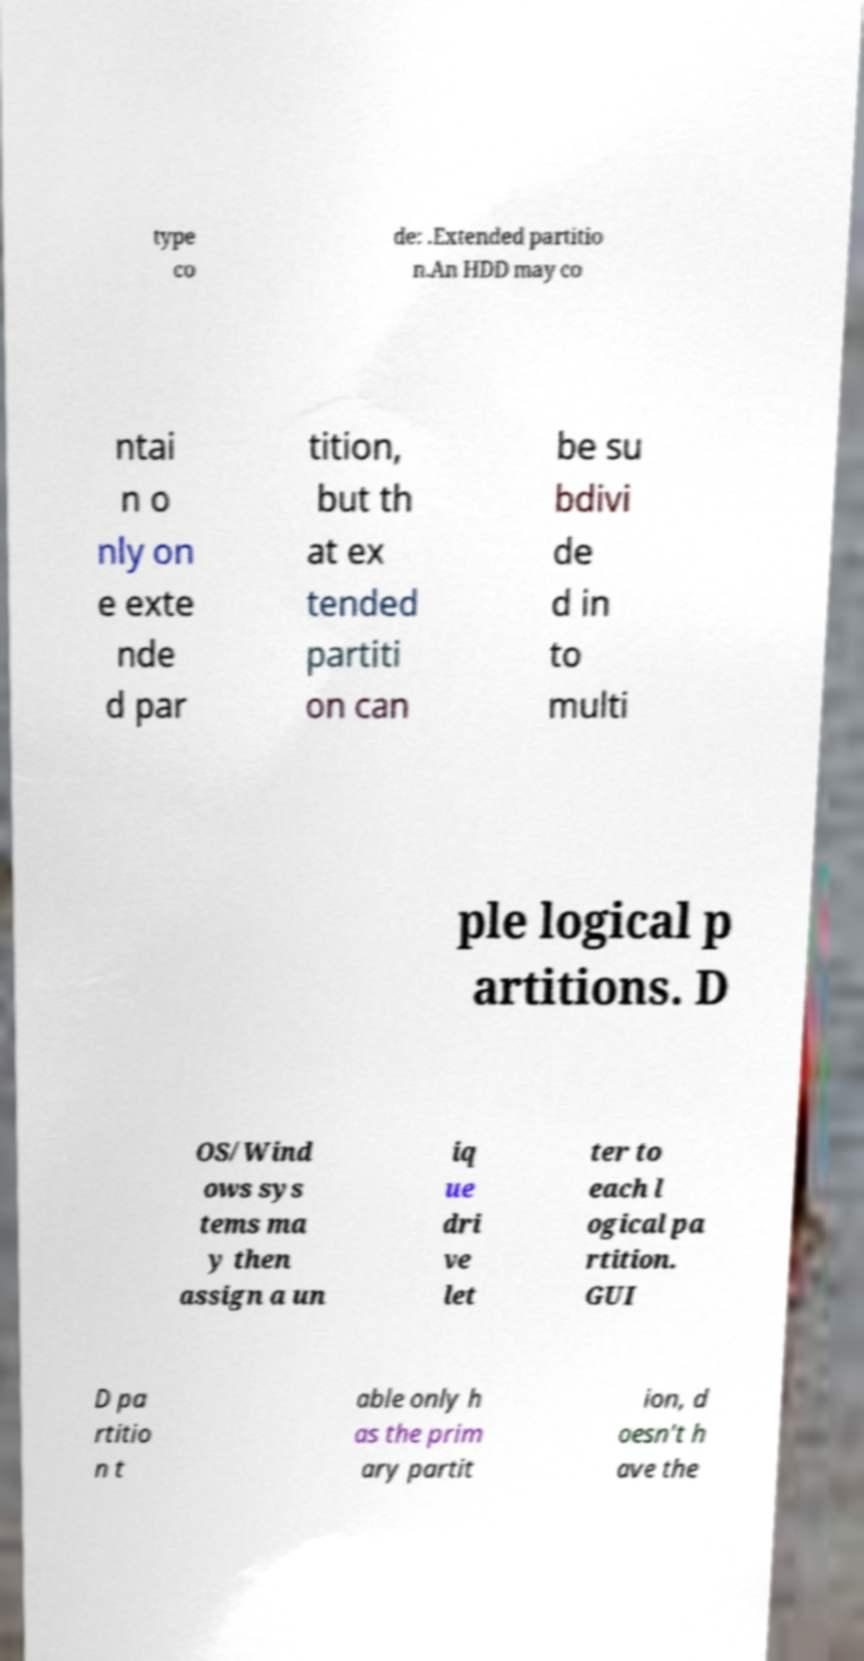For documentation purposes, I need the text within this image transcribed. Could you provide that? type co de: .Extended partitio n.An HDD may co ntai n o nly on e exte nde d par tition, but th at ex tended partiti on can be su bdivi de d in to multi ple logical p artitions. D OS/Wind ows sys tems ma y then assign a un iq ue dri ve let ter to each l ogical pa rtition. GUI D pa rtitio n t able only h as the prim ary partit ion, d oesn't h ave the 